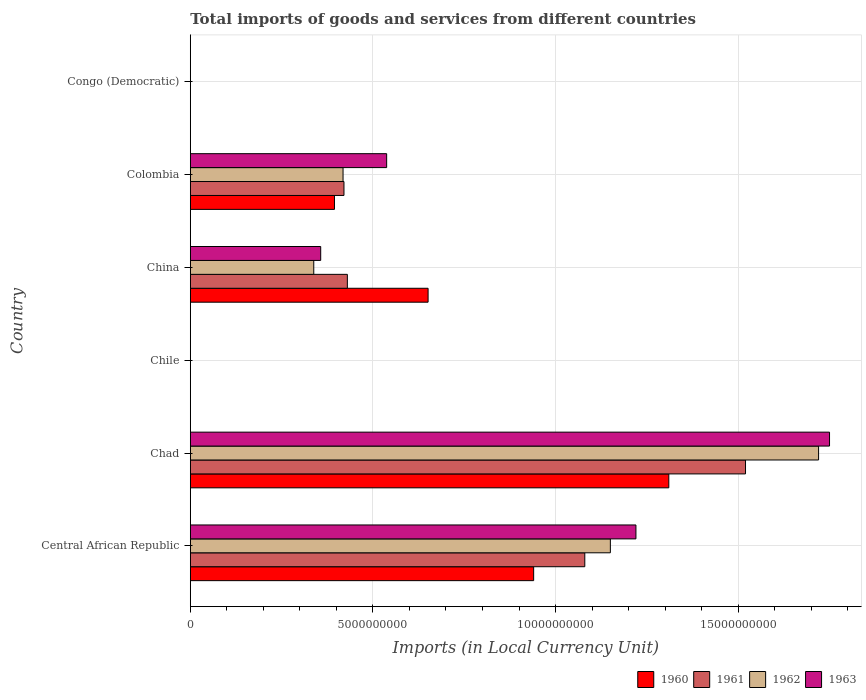Are the number of bars on each tick of the Y-axis equal?
Your answer should be very brief. Yes. How many bars are there on the 2nd tick from the top?
Provide a succinct answer. 4. How many bars are there on the 6th tick from the bottom?
Give a very brief answer. 4. What is the label of the 3rd group of bars from the top?
Give a very brief answer. China. What is the Amount of goods and services imports in 1960 in Central African Republic?
Give a very brief answer. 9.40e+09. Across all countries, what is the maximum Amount of goods and services imports in 1960?
Give a very brief answer. 1.31e+1. Across all countries, what is the minimum Amount of goods and services imports in 1960?
Your answer should be compact. 0. In which country was the Amount of goods and services imports in 1961 maximum?
Offer a very short reply. Chad. In which country was the Amount of goods and services imports in 1961 minimum?
Offer a very short reply. Congo (Democratic). What is the total Amount of goods and services imports in 1961 in the graph?
Your response must be concise. 3.45e+1. What is the difference between the Amount of goods and services imports in 1961 in Central African Republic and that in China?
Offer a terse response. 6.50e+09. What is the difference between the Amount of goods and services imports in 1962 in Chad and the Amount of goods and services imports in 1960 in Colombia?
Provide a succinct answer. 1.33e+1. What is the average Amount of goods and services imports in 1962 per country?
Your answer should be very brief. 6.04e+09. What is the difference between the Amount of goods and services imports in 1962 and Amount of goods and services imports in 1960 in Congo (Democratic)?
Make the answer very short. -5.182202221476458e-5. What is the ratio of the Amount of goods and services imports in 1962 in Chad to that in Colombia?
Ensure brevity in your answer.  4.11. Is the Amount of goods and services imports in 1963 in Central African Republic less than that in China?
Offer a terse response. No. Is the difference between the Amount of goods and services imports in 1962 in Central African Republic and Chile greater than the difference between the Amount of goods and services imports in 1960 in Central African Republic and Chile?
Provide a succinct answer. Yes. What is the difference between the highest and the second highest Amount of goods and services imports in 1960?
Offer a very short reply. 3.70e+09. What is the difference between the highest and the lowest Amount of goods and services imports in 1960?
Your response must be concise. 1.31e+1. In how many countries, is the Amount of goods and services imports in 1960 greater than the average Amount of goods and services imports in 1960 taken over all countries?
Ensure brevity in your answer.  3. Is the sum of the Amount of goods and services imports in 1960 in Central African Republic and China greater than the maximum Amount of goods and services imports in 1962 across all countries?
Keep it short and to the point. No. Is it the case that in every country, the sum of the Amount of goods and services imports in 1961 and Amount of goods and services imports in 1960 is greater than the sum of Amount of goods and services imports in 1963 and Amount of goods and services imports in 1962?
Make the answer very short. No. Is it the case that in every country, the sum of the Amount of goods and services imports in 1960 and Amount of goods and services imports in 1962 is greater than the Amount of goods and services imports in 1963?
Offer a terse response. No. How many bars are there?
Offer a terse response. 24. Are all the bars in the graph horizontal?
Keep it short and to the point. Yes. How are the legend labels stacked?
Provide a succinct answer. Horizontal. What is the title of the graph?
Offer a very short reply. Total imports of goods and services from different countries. Does "2015" appear as one of the legend labels in the graph?
Give a very brief answer. No. What is the label or title of the X-axis?
Provide a succinct answer. Imports (in Local Currency Unit). What is the Imports (in Local Currency Unit) in 1960 in Central African Republic?
Ensure brevity in your answer.  9.40e+09. What is the Imports (in Local Currency Unit) in 1961 in Central African Republic?
Your answer should be compact. 1.08e+1. What is the Imports (in Local Currency Unit) in 1962 in Central African Republic?
Keep it short and to the point. 1.15e+1. What is the Imports (in Local Currency Unit) in 1963 in Central African Republic?
Ensure brevity in your answer.  1.22e+1. What is the Imports (in Local Currency Unit) in 1960 in Chad?
Keep it short and to the point. 1.31e+1. What is the Imports (in Local Currency Unit) in 1961 in Chad?
Give a very brief answer. 1.52e+1. What is the Imports (in Local Currency Unit) of 1962 in Chad?
Give a very brief answer. 1.72e+1. What is the Imports (in Local Currency Unit) in 1963 in Chad?
Provide a short and direct response. 1.75e+1. What is the Imports (in Local Currency Unit) in 1960 in Chile?
Your answer should be compact. 7.00e+05. What is the Imports (in Local Currency Unit) in 1962 in Chile?
Ensure brevity in your answer.  8.00e+05. What is the Imports (in Local Currency Unit) of 1963 in Chile?
Make the answer very short. 1.30e+06. What is the Imports (in Local Currency Unit) of 1960 in China?
Your response must be concise. 6.51e+09. What is the Imports (in Local Currency Unit) in 1961 in China?
Make the answer very short. 4.30e+09. What is the Imports (in Local Currency Unit) in 1962 in China?
Make the answer very short. 3.38e+09. What is the Imports (in Local Currency Unit) of 1963 in China?
Keep it short and to the point. 3.57e+09. What is the Imports (in Local Currency Unit) in 1960 in Colombia?
Provide a succinct answer. 3.95e+09. What is the Imports (in Local Currency Unit) in 1961 in Colombia?
Provide a succinct answer. 4.21e+09. What is the Imports (in Local Currency Unit) of 1962 in Colombia?
Provide a succinct answer. 4.18e+09. What is the Imports (in Local Currency Unit) in 1963 in Colombia?
Provide a succinct answer. 5.38e+09. What is the Imports (in Local Currency Unit) in 1960 in Congo (Democratic)?
Make the answer very short. 0. What is the Imports (in Local Currency Unit) in 1961 in Congo (Democratic)?
Your answer should be compact. 5.07076656504069e-5. What is the Imports (in Local Currency Unit) of 1962 in Congo (Democratic)?
Your answer should be compact. 5.906629303353841e-5. What is the Imports (in Local Currency Unit) in 1963 in Congo (Democratic)?
Make the answer very short. 0. Across all countries, what is the maximum Imports (in Local Currency Unit) of 1960?
Ensure brevity in your answer.  1.31e+1. Across all countries, what is the maximum Imports (in Local Currency Unit) in 1961?
Your response must be concise. 1.52e+1. Across all countries, what is the maximum Imports (in Local Currency Unit) in 1962?
Keep it short and to the point. 1.72e+1. Across all countries, what is the maximum Imports (in Local Currency Unit) in 1963?
Keep it short and to the point. 1.75e+1. Across all countries, what is the minimum Imports (in Local Currency Unit) of 1960?
Keep it short and to the point. 0. Across all countries, what is the minimum Imports (in Local Currency Unit) of 1961?
Keep it short and to the point. 5.07076656504069e-5. Across all countries, what is the minimum Imports (in Local Currency Unit) in 1962?
Your answer should be very brief. 5.906629303353841e-5. Across all countries, what is the minimum Imports (in Local Currency Unit) in 1963?
Your answer should be very brief. 0. What is the total Imports (in Local Currency Unit) in 1960 in the graph?
Provide a succinct answer. 3.30e+1. What is the total Imports (in Local Currency Unit) in 1961 in the graph?
Offer a terse response. 3.45e+1. What is the total Imports (in Local Currency Unit) of 1962 in the graph?
Make the answer very short. 3.63e+1. What is the total Imports (in Local Currency Unit) of 1963 in the graph?
Make the answer very short. 3.86e+1. What is the difference between the Imports (in Local Currency Unit) of 1960 in Central African Republic and that in Chad?
Provide a succinct answer. -3.70e+09. What is the difference between the Imports (in Local Currency Unit) in 1961 in Central African Republic and that in Chad?
Provide a short and direct response. -4.40e+09. What is the difference between the Imports (in Local Currency Unit) of 1962 in Central African Republic and that in Chad?
Offer a terse response. -5.70e+09. What is the difference between the Imports (in Local Currency Unit) of 1963 in Central African Republic and that in Chad?
Offer a very short reply. -5.30e+09. What is the difference between the Imports (in Local Currency Unit) in 1960 in Central African Republic and that in Chile?
Provide a succinct answer. 9.40e+09. What is the difference between the Imports (in Local Currency Unit) of 1961 in Central African Republic and that in Chile?
Ensure brevity in your answer.  1.08e+1. What is the difference between the Imports (in Local Currency Unit) in 1962 in Central African Republic and that in Chile?
Provide a succinct answer. 1.15e+1. What is the difference between the Imports (in Local Currency Unit) in 1963 in Central African Republic and that in Chile?
Your answer should be compact. 1.22e+1. What is the difference between the Imports (in Local Currency Unit) of 1960 in Central African Republic and that in China?
Make the answer very short. 2.89e+09. What is the difference between the Imports (in Local Currency Unit) in 1961 in Central African Republic and that in China?
Keep it short and to the point. 6.50e+09. What is the difference between the Imports (in Local Currency Unit) in 1962 in Central African Republic and that in China?
Offer a terse response. 8.12e+09. What is the difference between the Imports (in Local Currency Unit) in 1963 in Central African Republic and that in China?
Give a very brief answer. 8.63e+09. What is the difference between the Imports (in Local Currency Unit) in 1960 in Central African Republic and that in Colombia?
Keep it short and to the point. 5.45e+09. What is the difference between the Imports (in Local Currency Unit) of 1961 in Central African Republic and that in Colombia?
Provide a short and direct response. 6.59e+09. What is the difference between the Imports (in Local Currency Unit) in 1962 in Central African Republic and that in Colombia?
Your response must be concise. 7.32e+09. What is the difference between the Imports (in Local Currency Unit) of 1963 in Central African Republic and that in Colombia?
Your answer should be very brief. 6.82e+09. What is the difference between the Imports (in Local Currency Unit) in 1960 in Central African Republic and that in Congo (Democratic)?
Offer a terse response. 9.40e+09. What is the difference between the Imports (in Local Currency Unit) of 1961 in Central African Republic and that in Congo (Democratic)?
Offer a very short reply. 1.08e+1. What is the difference between the Imports (in Local Currency Unit) of 1962 in Central African Republic and that in Congo (Democratic)?
Your answer should be very brief. 1.15e+1. What is the difference between the Imports (in Local Currency Unit) in 1963 in Central African Republic and that in Congo (Democratic)?
Provide a succinct answer. 1.22e+1. What is the difference between the Imports (in Local Currency Unit) in 1960 in Chad and that in Chile?
Your response must be concise. 1.31e+1. What is the difference between the Imports (in Local Currency Unit) in 1961 in Chad and that in Chile?
Provide a succinct answer. 1.52e+1. What is the difference between the Imports (in Local Currency Unit) of 1962 in Chad and that in Chile?
Your response must be concise. 1.72e+1. What is the difference between the Imports (in Local Currency Unit) in 1963 in Chad and that in Chile?
Provide a short and direct response. 1.75e+1. What is the difference between the Imports (in Local Currency Unit) in 1960 in Chad and that in China?
Provide a succinct answer. 6.59e+09. What is the difference between the Imports (in Local Currency Unit) of 1961 in Chad and that in China?
Make the answer very short. 1.09e+1. What is the difference between the Imports (in Local Currency Unit) in 1962 in Chad and that in China?
Give a very brief answer. 1.38e+1. What is the difference between the Imports (in Local Currency Unit) in 1963 in Chad and that in China?
Your answer should be compact. 1.39e+1. What is the difference between the Imports (in Local Currency Unit) of 1960 in Chad and that in Colombia?
Give a very brief answer. 9.15e+09. What is the difference between the Imports (in Local Currency Unit) of 1961 in Chad and that in Colombia?
Give a very brief answer. 1.10e+1. What is the difference between the Imports (in Local Currency Unit) in 1962 in Chad and that in Colombia?
Keep it short and to the point. 1.30e+1. What is the difference between the Imports (in Local Currency Unit) of 1963 in Chad and that in Colombia?
Make the answer very short. 1.21e+1. What is the difference between the Imports (in Local Currency Unit) of 1960 in Chad and that in Congo (Democratic)?
Provide a succinct answer. 1.31e+1. What is the difference between the Imports (in Local Currency Unit) of 1961 in Chad and that in Congo (Democratic)?
Your answer should be compact. 1.52e+1. What is the difference between the Imports (in Local Currency Unit) in 1962 in Chad and that in Congo (Democratic)?
Offer a very short reply. 1.72e+1. What is the difference between the Imports (in Local Currency Unit) of 1963 in Chad and that in Congo (Democratic)?
Offer a terse response. 1.75e+1. What is the difference between the Imports (in Local Currency Unit) in 1960 in Chile and that in China?
Your answer should be compact. -6.51e+09. What is the difference between the Imports (in Local Currency Unit) of 1961 in Chile and that in China?
Your answer should be very brief. -4.30e+09. What is the difference between the Imports (in Local Currency Unit) of 1962 in Chile and that in China?
Offer a terse response. -3.38e+09. What is the difference between the Imports (in Local Currency Unit) of 1963 in Chile and that in China?
Offer a very short reply. -3.57e+09. What is the difference between the Imports (in Local Currency Unit) in 1960 in Chile and that in Colombia?
Offer a very short reply. -3.95e+09. What is the difference between the Imports (in Local Currency Unit) of 1961 in Chile and that in Colombia?
Make the answer very short. -4.21e+09. What is the difference between the Imports (in Local Currency Unit) of 1962 in Chile and that in Colombia?
Give a very brief answer. -4.18e+09. What is the difference between the Imports (in Local Currency Unit) in 1963 in Chile and that in Colombia?
Your response must be concise. -5.37e+09. What is the difference between the Imports (in Local Currency Unit) of 1960 in Chile and that in Congo (Democratic)?
Provide a short and direct response. 7.00e+05. What is the difference between the Imports (in Local Currency Unit) in 1961 in Chile and that in Congo (Democratic)?
Provide a short and direct response. 8.00e+05. What is the difference between the Imports (in Local Currency Unit) of 1962 in Chile and that in Congo (Democratic)?
Your answer should be very brief. 8.00e+05. What is the difference between the Imports (in Local Currency Unit) of 1963 in Chile and that in Congo (Democratic)?
Provide a short and direct response. 1.30e+06. What is the difference between the Imports (in Local Currency Unit) in 1960 in China and that in Colombia?
Make the answer very short. 2.56e+09. What is the difference between the Imports (in Local Currency Unit) of 1961 in China and that in Colombia?
Offer a terse response. 9.28e+07. What is the difference between the Imports (in Local Currency Unit) of 1962 in China and that in Colombia?
Give a very brief answer. -8.02e+08. What is the difference between the Imports (in Local Currency Unit) in 1963 in China and that in Colombia?
Your answer should be very brief. -1.81e+09. What is the difference between the Imports (in Local Currency Unit) in 1960 in China and that in Congo (Democratic)?
Your answer should be compact. 6.51e+09. What is the difference between the Imports (in Local Currency Unit) in 1961 in China and that in Congo (Democratic)?
Keep it short and to the point. 4.30e+09. What is the difference between the Imports (in Local Currency Unit) of 1962 in China and that in Congo (Democratic)?
Give a very brief answer. 3.38e+09. What is the difference between the Imports (in Local Currency Unit) in 1963 in China and that in Congo (Democratic)?
Your answer should be compact. 3.57e+09. What is the difference between the Imports (in Local Currency Unit) of 1960 in Colombia and that in Congo (Democratic)?
Offer a very short reply. 3.95e+09. What is the difference between the Imports (in Local Currency Unit) in 1961 in Colombia and that in Congo (Democratic)?
Ensure brevity in your answer.  4.21e+09. What is the difference between the Imports (in Local Currency Unit) in 1962 in Colombia and that in Congo (Democratic)?
Give a very brief answer. 4.18e+09. What is the difference between the Imports (in Local Currency Unit) in 1963 in Colombia and that in Congo (Democratic)?
Provide a short and direct response. 5.38e+09. What is the difference between the Imports (in Local Currency Unit) of 1960 in Central African Republic and the Imports (in Local Currency Unit) of 1961 in Chad?
Your answer should be compact. -5.80e+09. What is the difference between the Imports (in Local Currency Unit) of 1960 in Central African Republic and the Imports (in Local Currency Unit) of 1962 in Chad?
Provide a succinct answer. -7.80e+09. What is the difference between the Imports (in Local Currency Unit) in 1960 in Central African Republic and the Imports (in Local Currency Unit) in 1963 in Chad?
Give a very brief answer. -8.10e+09. What is the difference between the Imports (in Local Currency Unit) in 1961 in Central African Republic and the Imports (in Local Currency Unit) in 1962 in Chad?
Provide a succinct answer. -6.40e+09. What is the difference between the Imports (in Local Currency Unit) of 1961 in Central African Republic and the Imports (in Local Currency Unit) of 1963 in Chad?
Provide a short and direct response. -6.70e+09. What is the difference between the Imports (in Local Currency Unit) of 1962 in Central African Republic and the Imports (in Local Currency Unit) of 1963 in Chad?
Your answer should be very brief. -6.00e+09. What is the difference between the Imports (in Local Currency Unit) in 1960 in Central African Republic and the Imports (in Local Currency Unit) in 1961 in Chile?
Ensure brevity in your answer.  9.40e+09. What is the difference between the Imports (in Local Currency Unit) in 1960 in Central African Republic and the Imports (in Local Currency Unit) in 1962 in Chile?
Ensure brevity in your answer.  9.40e+09. What is the difference between the Imports (in Local Currency Unit) of 1960 in Central African Republic and the Imports (in Local Currency Unit) of 1963 in Chile?
Provide a short and direct response. 9.40e+09. What is the difference between the Imports (in Local Currency Unit) of 1961 in Central African Republic and the Imports (in Local Currency Unit) of 1962 in Chile?
Make the answer very short. 1.08e+1. What is the difference between the Imports (in Local Currency Unit) of 1961 in Central African Republic and the Imports (in Local Currency Unit) of 1963 in Chile?
Ensure brevity in your answer.  1.08e+1. What is the difference between the Imports (in Local Currency Unit) of 1962 in Central African Republic and the Imports (in Local Currency Unit) of 1963 in Chile?
Keep it short and to the point. 1.15e+1. What is the difference between the Imports (in Local Currency Unit) in 1960 in Central African Republic and the Imports (in Local Currency Unit) in 1961 in China?
Offer a very short reply. 5.10e+09. What is the difference between the Imports (in Local Currency Unit) of 1960 in Central African Republic and the Imports (in Local Currency Unit) of 1962 in China?
Keep it short and to the point. 6.02e+09. What is the difference between the Imports (in Local Currency Unit) in 1960 in Central African Republic and the Imports (in Local Currency Unit) in 1963 in China?
Make the answer very short. 5.83e+09. What is the difference between the Imports (in Local Currency Unit) of 1961 in Central African Republic and the Imports (in Local Currency Unit) of 1962 in China?
Keep it short and to the point. 7.42e+09. What is the difference between the Imports (in Local Currency Unit) in 1961 in Central African Republic and the Imports (in Local Currency Unit) in 1963 in China?
Offer a very short reply. 7.23e+09. What is the difference between the Imports (in Local Currency Unit) in 1962 in Central African Republic and the Imports (in Local Currency Unit) in 1963 in China?
Provide a succinct answer. 7.93e+09. What is the difference between the Imports (in Local Currency Unit) in 1960 in Central African Republic and the Imports (in Local Currency Unit) in 1961 in Colombia?
Your response must be concise. 5.19e+09. What is the difference between the Imports (in Local Currency Unit) of 1960 in Central African Republic and the Imports (in Local Currency Unit) of 1962 in Colombia?
Make the answer very short. 5.22e+09. What is the difference between the Imports (in Local Currency Unit) of 1960 in Central African Republic and the Imports (in Local Currency Unit) of 1963 in Colombia?
Keep it short and to the point. 4.02e+09. What is the difference between the Imports (in Local Currency Unit) in 1961 in Central African Republic and the Imports (in Local Currency Unit) in 1962 in Colombia?
Offer a terse response. 6.62e+09. What is the difference between the Imports (in Local Currency Unit) in 1961 in Central African Republic and the Imports (in Local Currency Unit) in 1963 in Colombia?
Give a very brief answer. 5.42e+09. What is the difference between the Imports (in Local Currency Unit) of 1962 in Central African Republic and the Imports (in Local Currency Unit) of 1963 in Colombia?
Your response must be concise. 6.12e+09. What is the difference between the Imports (in Local Currency Unit) of 1960 in Central African Republic and the Imports (in Local Currency Unit) of 1961 in Congo (Democratic)?
Provide a succinct answer. 9.40e+09. What is the difference between the Imports (in Local Currency Unit) in 1960 in Central African Republic and the Imports (in Local Currency Unit) in 1962 in Congo (Democratic)?
Offer a very short reply. 9.40e+09. What is the difference between the Imports (in Local Currency Unit) in 1960 in Central African Republic and the Imports (in Local Currency Unit) in 1963 in Congo (Democratic)?
Offer a terse response. 9.40e+09. What is the difference between the Imports (in Local Currency Unit) in 1961 in Central African Republic and the Imports (in Local Currency Unit) in 1962 in Congo (Democratic)?
Provide a succinct answer. 1.08e+1. What is the difference between the Imports (in Local Currency Unit) in 1961 in Central African Republic and the Imports (in Local Currency Unit) in 1963 in Congo (Democratic)?
Offer a very short reply. 1.08e+1. What is the difference between the Imports (in Local Currency Unit) in 1962 in Central African Republic and the Imports (in Local Currency Unit) in 1963 in Congo (Democratic)?
Give a very brief answer. 1.15e+1. What is the difference between the Imports (in Local Currency Unit) of 1960 in Chad and the Imports (in Local Currency Unit) of 1961 in Chile?
Make the answer very short. 1.31e+1. What is the difference between the Imports (in Local Currency Unit) of 1960 in Chad and the Imports (in Local Currency Unit) of 1962 in Chile?
Give a very brief answer. 1.31e+1. What is the difference between the Imports (in Local Currency Unit) of 1960 in Chad and the Imports (in Local Currency Unit) of 1963 in Chile?
Your answer should be very brief. 1.31e+1. What is the difference between the Imports (in Local Currency Unit) of 1961 in Chad and the Imports (in Local Currency Unit) of 1962 in Chile?
Offer a terse response. 1.52e+1. What is the difference between the Imports (in Local Currency Unit) in 1961 in Chad and the Imports (in Local Currency Unit) in 1963 in Chile?
Provide a short and direct response. 1.52e+1. What is the difference between the Imports (in Local Currency Unit) in 1962 in Chad and the Imports (in Local Currency Unit) in 1963 in Chile?
Provide a succinct answer. 1.72e+1. What is the difference between the Imports (in Local Currency Unit) of 1960 in Chad and the Imports (in Local Currency Unit) of 1961 in China?
Ensure brevity in your answer.  8.80e+09. What is the difference between the Imports (in Local Currency Unit) in 1960 in Chad and the Imports (in Local Currency Unit) in 1962 in China?
Provide a succinct answer. 9.72e+09. What is the difference between the Imports (in Local Currency Unit) in 1960 in Chad and the Imports (in Local Currency Unit) in 1963 in China?
Provide a short and direct response. 9.53e+09. What is the difference between the Imports (in Local Currency Unit) of 1961 in Chad and the Imports (in Local Currency Unit) of 1962 in China?
Offer a terse response. 1.18e+1. What is the difference between the Imports (in Local Currency Unit) in 1961 in Chad and the Imports (in Local Currency Unit) in 1963 in China?
Provide a succinct answer. 1.16e+1. What is the difference between the Imports (in Local Currency Unit) in 1962 in Chad and the Imports (in Local Currency Unit) in 1963 in China?
Provide a succinct answer. 1.36e+1. What is the difference between the Imports (in Local Currency Unit) in 1960 in Chad and the Imports (in Local Currency Unit) in 1961 in Colombia?
Your response must be concise. 8.89e+09. What is the difference between the Imports (in Local Currency Unit) of 1960 in Chad and the Imports (in Local Currency Unit) of 1962 in Colombia?
Give a very brief answer. 8.92e+09. What is the difference between the Imports (in Local Currency Unit) of 1960 in Chad and the Imports (in Local Currency Unit) of 1963 in Colombia?
Provide a short and direct response. 7.72e+09. What is the difference between the Imports (in Local Currency Unit) of 1961 in Chad and the Imports (in Local Currency Unit) of 1962 in Colombia?
Your answer should be compact. 1.10e+1. What is the difference between the Imports (in Local Currency Unit) of 1961 in Chad and the Imports (in Local Currency Unit) of 1963 in Colombia?
Your response must be concise. 9.82e+09. What is the difference between the Imports (in Local Currency Unit) in 1962 in Chad and the Imports (in Local Currency Unit) in 1963 in Colombia?
Offer a very short reply. 1.18e+1. What is the difference between the Imports (in Local Currency Unit) in 1960 in Chad and the Imports (in Local Currency Unit) in 1961 in Congo (Democratic)?
Give a very brief answer. 1.31e+1. What is the difference between the Imports (in Local Currency Unit) of 1960 in Chad and the Imports (in Local Currency Unit) of 1962 in Congo (Democratic)?
Ensure brevity in your answer.  1.31e+1. What is the difference between the Imports (in Local Currency Unit) in 1960 in Chad and the Imports (in Local Currency Unit) in 1963 in Congo (Democratic)?
Offer a very short reply. 1.31e+1. What is the difference between the Imports (in Local Currency Unit) in 1961 in Chad and the Imports (in Local Currency Unit) in 1962 in Congo (Democratic)?
Make the answer very short. 1.52e+1. What is the difference between the Imports (in Local Currency Unit) in 1961 in Chad and the Imports (in Local Currency Unit) in 1963 in Congo (Democratic)?
Your response must be concise. 1.52e+1. What is the difference between the Imports (in Local Currency Unit) in 1962 in Chad and the Imports (in Local Currency Unit) in 1963 in Congo (Democratic)?
Provide a succinct answer. 1.72e+1. What is the difference between the Imports (in Local Currency Unit) in 1960 in Chile and the Imports (in Local Currency Unit) in 1961 in China?
Your response must be concise. -4.30e+09. What is the difference between the Imports (in Local Currency Unit) of 1960 in Chile and the Imports (in Local Currency Unit) of 1962 in China?
Ensure brevity in your answer.  -3.38e+09. What is the difference between the Imports (in Local Currency Unit) in 1960 in Chile and the Imports (in Local Currency Unit) in 1963 in China?
Offer a terse response. -3.57e+09. What is the difference between the Imports (in Local Currency Unit) in 1961 in Chile and the Imports (in Local Currency Unit) in 1962 in China?
Provide a succinct answer. -3.38e+09. What is the difference between the Imports (in Local Currency Unit) in 1961 in Chile and the Imports (in Local Currency Unit) in 1963 in China?
Your response must be concise. -3.57e+09. What is the difference between the Imports (in Local Currency Unit) of 1962 in Chile and the Imports (in Local Currency Unit) of 1963 in China?
Your answer should be compact. -3.57e+09. What is the difference between the Imports (in Local Currency Unit) in 1960 in Chile and the Imports (in Local Currency Unit) in 1961 in Colombia?
Provide a succinct answer. -4.21e+09. What is the difference between the Imports (in Local Currency Unit) in 1960 in Chile and the Imports (in Local Currency Unit) in 1962 in Colombia?
Your answer should be very brief. -4.18e+09. What is the difference between the Imports (in Local Currency Unit) in 1960 in Chile and the Imports (in Local Currency Unit) in 1963 in Colombia?
Your answer should be very brief. -5.37e+09. What is the difference between the Imports (in Local Currency Unit) in 1961 in Chile and the Imports (in Local Currency Unit) in 1962 in Colombia?
Provide a succinct answer. -4.18e+09. What is the difference between the Imports (in Local Currency Unit) of 1961 in Chile and the Imports (in Local Currency Unit) of 1963 in Colombia?
Keep it short and to the point. -5.37e+09. What is the difference between the Imports (in Local Currency Unit) in 1962 in Chile and the Imports (in Local Currency Unit) in 1963 in Colombia?
Provide a short and direct response. -5.37e+09. What is the difference between the Imports (in Local Currency Unit) in 1960 in Chile and the Imports (in Local Currency Unit) in 1961 in Congo (Democratic)?
Provide a short and direct response. 7.00e+05. What is the difference between the Imports (in Local Currency Unit) in 1960 in Chile and the Imports (in Local Currency Unit) in 1962 in Congo (Democratic)?
Offer a terse response. 7.00e+05. What is the difference between the Imports (in Local Currency Unit) in 1960 in Chile and the Imports (in Local Currency Unit) in 1963 in Congo (Democratic)?
Offer a very short reply. 7.00e+05. What is the difference between the Imports (in Local Currency Unit) of 1961 in Chile and the Imports (in Local Currency Unit) of 1962 in Congo (Democratic)?
Your answer should be very brief. 8.00e+05. What is the difference between the Imports (in Local Currency Unit) of 1961 in Chile and the Imports (in Local Currency Unit) of 1963 in Congo (Democratic)?
Provide a short and direct response. 8.00e+05. What is the difference between the Imports (in Local Currency Unit) of 1962 in Chile and the Imports (in Local Currency Unit) of 1963 in Congo (Democratic)?
Your answer should be very brief. 8.00e+05. What is the difference between the Imports (in Local Currency Unit) in 1960 in China and the Imports (in Local Currency Unit) in 1961 in Colombia?
Your response must be concise. 2.30e+09. What is the difference between the Imports (in Local Currency Unit) in 1960 in China and the Imports (in Local Currency Unit) in 1962 in Colombia?
Your answer should be compact. 2.33e+09. What is the difference between the Imports (in Local Currency Unit) of 1960 in China and the Imports (in Local Currency Unit) of 1963 in Colombia?
Provide a short and direct response. 1.13e+09. What is the difference between the Imports (in Local Currency Unit) in 1961 in China and the Imports (in Local Currency Unit) in 1962 in Colombia?
Your response must be concise. 1.18e+08. What is the difference between the Imports (in Local Currency Unit) of 1961 in China and the Imports (in Local Currency Unit) of 1963 in Colombia?
Provide a succinct answer. -1.08e+09. What is the difference between the Imports (in Local Currency Unit) of 1962 in China and the Imports (in Local Currency Unit) of 1963 in Colombia?
Ensure brevity in your answer.  -2.00e+09. What is the difference between the Imports (in Local Currency Unit) in 1960 in China and the Imports (in Local Currency Unit) in 1961 in Congo (Democratic)?
Offer a very short reply. 6.51e+09. What is the difference between the Imports (in Local Currency Unit) of 1960 in China and the Imports (in Local Currency Unit) of 1962 in Congo (Democratic)?
Offer a very short reply. 6.51e+09. What is the difference between the Imports (in Local Currency Unit) in 1960 in China and the Imports (in Local Currency Unit) in 1963 in Congo (Democratic)?
Keep it short and to the point. 6.51e+09. What is the difference between the Imports (in Local Currency Unit) of 1961 in China and the Imports (in Local Currency Unit) of 1962 in Congo (Democratic)?
Offer a very short reply. 4.30e+09. What is the difference between the Imports (in Local Currency Unit) of 1961 in China and the Imports (in Local Currency Unit) of 1963 in Congo (Democratic)?
Your answer should be compact. 4.30e+09. What is the difference between the Imports (in Local Currency Unit) of 1962 in China and the Imports (in Local Currency Unit) of 1963 in Congo (Democratic)?
Offer a very short reply. 3.38e+09. What is the difference between the Imports (in Local Currency Unit) in 1960 in Colombia and the Imports (in Local Currency Unit) in 1961 in Congo (Democratic)?
Your answer should be very brief. 3.95e+09. What is the difference between the Imports (in Local Currency Unit) of 1960 in Colombia and the Imports (in Local Currency Unit) of 1962 in Congo (Democratic)?
Keep it short and to the point. 3.95e+09. What is the difference between the Imports (in Local Currency Unit) of 1960 in Colombia and the Imports (in Local Currency Unit) of 1963 in Congo (Democratic)?
Your answer should be compact. 3.95e+09. What is the difference between the Imports (in Local Currency Unit) in 1961 in Colombia and the Imports (in Local Currency Unit) in 1962 in Congo (Democratic)?
Your answer should be very brief. 4.21e+09. What is the difference between the Imports (in Local Currency Unit) of 1961 in Colombia and the Imports (in Local Currency Unit) of 1963 in Congo (Democratic)?
Provide a short and direct response. 4.21e+09. What is the difference between the Imports (in Local Currency Unit) in 1962 in Colombia and the Imports (in Local Currency Unit) in 1963 in Congo (Democratic)?
Your answer should be very brief. 4.18e+09. What is the average Imports (in Local Currency Unit) in 1960 per country?
Provide a short and direct response. 5.49e+09. What is the average Imports (in Local Currency Unit) of 1961 per country?
Ensure brevity in your answer.  5.75e+09. What is the average Imports (in Local Currency Unit) in 1962 per country?
Give a very brief answer. 6.04e+09. What is the average Imports (in Local Currency Unit) of 1963 per country?
Your answer should be compact. 6.44e+09. What is the difference between the Imports (in Local Currency Unit) in 1960 and Imports (in Local Currency Unit) in 1961 in Central African Republic?
Your answer should be very brief. -1.40e+09. What is the difference between the Imports (in Local Currency Unit) in 1960 and Imports (in Local Currency Unit) in 1962 in Central African Republic?
Make the answer very short. -2.10e+09. What is the difference between the Imports (in Local Currency Unit) in 1960 and Imports (in Local Currency Unit) in 1963 in Central African Republic?
Provide a succinct answer. -2.80e+09. What is the difference between the Imports (in Local Currency Unit) of 1961 and Imports (in Local Currency Unit) of 1962 in Central African Republic?
Your response must be concise. -7.00e+08. What is the difference between the Imports (in Local Currency Unit) of 1961 and Imports (in Local Currency Unit) of 1963 in Central African Republic?
Your answer should be very brief. -1.40e+09. What is the difference between the Imports (in Local Currency Unit) in 1962 and Imports (in Local Currency Unit) in 1963 in Central African Republic?
Make the answer very short. -7.00e+08. What is the difference between the Imports (in Local Currency Unit) in 1960 and Imports (in Local Currency Unit) in 1961 in Chad?
Give a very brief answer. -2.10e+09. What is the difference between the Imports (in Local Currency Unit) of 1960 and Imports (in Local Currency Unit) of 1962 in Chad?
Offer a terse response. -4.10e+09. What is the difference between the Imports (in Local Currency Unit) in 1960 and Imports (in Local Currency Unit) in 1963 in Chad?
Provide a short and direct response. -4.40e+09. What is the difference between the Imports (in Local Currency Unit) in 1961 and Imports (in Local Currency Unit) in 1962 in Chad?
Ensure brevity in your answer.  -2.00e+09. What is the difference between the Imports (in Local Currency Unit) of 1961 and Imports (in Local Currency Unit) of 1963 in Chad?
Make the answer very short. -2.30e+09. What is the difference between the Imports (in Local Currency Unit) of 1962 and Imports (in Local Currency Unit) of 1963 in Chad?
Ensure brevity in your answer.  -3.00e+08. What is the difference between the Imports (in Local Currency Unit) of 1960 and Imports (in Local Currency Unit) of 1961 in Chile?
Provide a short and direct response. -1.00e+05. What is the difference between the Imports (in Local Currency Unit) in 1960 and Imports (in Local Currency Unit) in 1963 in Chile?
Provide a succinct answer. -6.00e+05. What is the difference between the Imports (in Local Currency Unit) of 1961 and Imports (in Local Currency Unit) of 1963 in Chile?
Provide a succinct answer. -5.00e+05. What is the difference between the Imports (in Local Currency Unit) in 1962 and Imports (in Local Currency Unit) in 1963 in Chile?
Make the answer very short. -5.00e+05. What is the difference between the Imports (in Local Currency Unit) of 1960 and Imports (in Local Currency Unit) of 1961 in China?
Your answer should be very brief. 2.21e+09. What is the difference between the Imports (in Local Currency Unit) of 1960 and Imports (in Local Currency Unit) of 1962 in China?
Provide a succinct answer. 3.13e+09. What is the difference between the Imports (in Local Currency Unit) in 1960 and Imports (in Local Currency Unit) in 1963 in China?
Offer a very short reply. 2.94e+09. What is the difference between the Imports (in Local Currency Unit) of 1961 and Imports (in Local Currency Unit) of 1962 in China?
Offer a very short reply. 9.20e+08. What is the difference between the Imports (in Local Currency Unit) of 1961 and Imports (in Local Currency Unit) of 1963 in China?
Ensure brevity in your answer.  7.30e+08. What is the difference between the Imports (in Local Currency Unit) in 1962 and Imports (in Local Currency Unit) in 1963 in China?
Offer a terse response. -1.90e+08. What is the difference between the Imports (in Local Currency Unit) in 1960 and Imports (in Local Currency Unit) in 1961 in Colombia?
Provide a short and direct response. -2.60e+08. What is the difference between the Imports (in Local Currency Unit) of 1960 and Imports (in Local Currency Unit) of 1962 in Colombia?
Offer a terse response. -2.35e+08. What is the difference between the Imports (in Local Currency Unit) in 1960 and Imports (in Local Currency Unit) in 1963 in Colombia?
Offer a terse response. -1.43e+09. What is the difference between the Imports (in Local Currency Unit) in 1961 and Imports (in Local Currency Unit) in 1962 in Colombia?
Offer a very short reply. 2.55e+07. What is the difference between the Imports (in Local Currency Unit) in 1961 and Imports (in Local Currency Unit) in 1963 in Colombia?
Offer a very short reply. -1.17e+09. What is the difference between the Imports (in Local Currency Unit) of 1962 and Imports (in Local Currency Unit) of 1963 in Colombia?
Make the answer very short. -1.19e+09. What is the difference between the Imports (in Local Currency Unit) in 1960 and Imports (in Local Currency Unit) in 1961 in Congo (Democratic)?
Offer a very short reply. 0. What is the difference between the Imports (in Local Currency Unit) of 1960 and Imports (in Local Currency Unit) of 1963 in Congo (Democratic)?
Make the answer very short. -0. What is the difference between the Imports (in Local Currency Unit) in 1961 and Imports (in Local Currency Unit) in 1963 in Congo (Democratic)?
Provide a succinct answer. -0. What is the difference between the Imports (in Local Currency Unit) in 1962 and Imports (in Local Currency Unit) in 1963 in Congo (Democratic)?
Make the answer very short. -0. What is the ratio of the Imports (in Local Currency Unit) of 1960 in Central African Republic to that in Chad?
Ensure brevity in your answer.  0.72. What is the ratio of the Imports (in Local Currency Unit) of 1961 in Central African Republic to that in Chad?
Offer a terse response. 0.71. What is the ratio of the Imports (in Local Currency Unit) in 1962 in Central African Republic to that in Chad?
Your answer should be very brief. 0.67. What is the ratio of the Imports (in Local Currency Unit) of 1963 in Central African Republic to that in Chad?
Offer a very short reply. 0.7. What is the ratio of the Imports (in Local Currency Unit) of 1960 in Central African Republic to that in Chile?
Your answer should be very brief. 1.34e+04. What is the ratio of the Imports (in Local Currency Unit) of 1961 in Central African Republic to that in Chile?
Your answer should be compact. 1.35e+04. What is the ratio of the Imports (in Local Currency Unit) in 1962 in Central African Republic to that in Chile?
Your answer should be very brief. 1.44e+04. What is the ratio of the Imports (in Local Currency Unit) of 1963 in Central African Republic to that in Chile?
Ensure brevity in your answer.  9384.62. What is the ratio of the Imports (in Local Currency Unit) of 1960 in Central African Republic to that in China?
Make the answer very short. 1.44. What is the ratio of the Imports (in Local Currency Unit) in 1961 in Central African Republic to that in China?
Ensure brevity in your answer.  2.51. What is the ratio of the Imports (in Local Currency Unit) in 1962 in Central African Republic to that in China?
Provide a short and direct response. 3.4. What is the ratio of the Imports (in Local Currency Unit) in 1963 in Central African Republic to that in China?
Ensure brevity in your answer.  3.42. What is the ratio of the Imports (in Local Currency Unit) of 1960 in Central African Republic to that in Colombia?
Keep it short and to the point. 2.38. What is the ratio of the Imports (in Local Currency Unit) of 1961 in Central African Republic to that in Colombia?
Your answer should be compact. 2.57. What is the ratio of the Imports (in Local Currency Unit) of 1962 in Central African Republic to that in Colombia?
Keep it short and to the point. 2.75. What is the ratio of the Imports (in Local Currency Unit) of 1963 in Central African Republic to that in Colombia?
Ensure brevity in your answer.  2.27. What is the ratio of the Imports (in Local Currency Unit) of 1960 in Central African Republic to that in Congo (Democratic)?
Give a very brief answer. 8.48e+13. What is the ratio of the Imports (in Local Currency Unit) of 1961 in Central African Republic to that in Congo (Democratic)?
Your response must be concise. 2.13e+14. What is the ratio of the Imports (in Local Currency Unit) in 1962 in Central African Republic to that in Congo (Democratic)?
Offer a very short reply. 1.95e+14. What is the ratio of the Imports (in Local Currency Unit) in 1963 in Central African Republic to that in Congo (Democratic)?
Provide a short and direct response. 2.45e+13. What is the ratio of the Imports (in Local Currency Unit) of 1960 in Chad to that in Chile?
Make the answer very short. 1.87e+04. What is the ratio of the Imports (in Local Currency Unit) in 1961 in Chad to that in Chile?
Make the answer very short. 1.90e+04. What is the ratio of the Imports (in Local Currency Unit) in 1962 in Chad to that in Chile?
Make the answer very short. 2.15e+04. What is the ratio of the Imports (in Local Currency Unit) of 1963 in Chad to that in Chile?
Offer a very short reply. 1.35e+04. What is the ratio of the Imports (in Local Currency Unit) of 1960 in Chad to that in China?
Make the answer very short. 2.01. What is the ratio of the Imports (in Local Currency Unit) of 1961 in Chad to that in China?
Give a very brief answer. 3.53. What is the ratio of the Imports (in Local Currency Unit) of 1962 in Chad to that in China?
Offer a very short reply. 5.09. What is the ratio of the Imports (in Local Currency Unit) in 1963 in Chad to that in China?
Give a very brief answer. 4.9. What is the ratio of the Imports (in Local Currency Unit) of 1960 in Chad to that in Colombia?
Give a very brief answer. 3.32. What is the ratio of the Imports (in Local Currency Unit) in 1961 in Chad to that in Colombia?
Give a very brief answer. 3.61. What is the ratio of the Imports (in Local Currency Unit) of 1962 in Chad to that in Colombia?
Ensure brevity in your answer.  4.11. What is the ratio of the Imports (in Local Currency Unit) of 1963 in Chad to that in Colombia?
Offer a terse response. 3.26. What is the ratio of the Imports (in Local Currency Unit) of 1960 in Chad to that in Congo (Democratic)?
Your response must be concise. 1.18e+14. What is the ratio of the Imports (in Local Currency Unit) in 1961 in Chad to that in Congo (Democratic)?
Offer a terse response. 3.00e+14. What is the ratio of the Imports (in Local Currency Unit) in 1962 in Chad to that in Congo (Democratic)?
Offer a terse response. 2.91e+14. What is the ratio of the Imports (in Local Currency Unit) in 1963 in Chad to that in Congo (Democratic)?
Provide a short and direct response. 3.52e+13. What is the ratio of the Imports (in Local Currency Unit) of 1961 in Chile to that in China?
Your answer should be very brief. 0. What is the ratio of the Imports (in Local Currency Unit) of 1960 in Chile to that in Colombia?
Provide a succinct answer. 0. What is the ratio of the Imports (in Local Currency Unit) in 1962 in Chile to that in Colombia?
Your answer should be very brief. 0. What is the ratio of the Imports (in Local Currency Unit) of 1960 in Chile to that in Congo (Democratic)?
Give a very brief answer. 6.31e+09. What is the ratio of the Imports (in Local Currency Unit) in 1961 in Chile to that in Congo (Democratic)?
Ensure brevity in your answer.  1.58e+1. What is the ratio of the Imports (in Local Currency Unit) of 1962 in Chile to that in Congo (Democratic)?
Your answer should be compact. 1.35e+1. What is the ratio of the Imports (in Local Currency Unit) in 1963 in Chile to that in Congo (Democratic)?
Your answer should be very brief. 2.62e+09. What is the ratio of the Imports (in Local Currency Unit) of 1960 in China to that in Colombia?
Make the answer very short. 1.65. What is the ratio of the Imports (in Local Currency Unit) in 1961 in China to that in Colombia?
Offer a terse response. 1.02. What is the ratio of the Imports (in Local Currency Unit) of 1962 in China to that in Colombia?
Offer a terse response. 0.81. What is the ratio of the Imports (in Local Currency Unit) of 1963 in China to that in Colombia?
Keep it short and to the point. 0.66. What is the ratio of the Imports (in Local Currency Unit) in 1960 in China to that in Congo (Democratic)?
Provide a short and direct response. 5.87e+13. What is the ratio of the Imports (in Local Currency Unit) in 1961 in China to that in Congo (Democratic)?
Give a very brief answer. 8.48e+13. What is the ratio of the Imports (in Local Currency Unit) in 1962 in China to that in Congo (Democratic)?
Your response must be concise. 5.72e+13. What is the ratio of the Imports (in Local Currency Unit) of 1963 in China to that in Congo (Democratic)?
Ensure brevity in your answer.  7.18e+12. What is the ratio of the Imports (in Local Currency Unit) in 1960 in Colombia to that in Congo (Democratic)?
Make the answer very short. 3.56e+13. What is the ratio of the Imports (in Local Currency Unit) of 1961 in Colombia to that in Congo (Democratic)?
Make the answer very short. 8.30e+13. What is the ratio of the Imports (in Local Currency Unit) in 1962 in Colombia to that in Congo (Democratic)?
Ensure brevity in your answer.  7.08e+13. What is the ratio of the Imports (in Local Currency Unit) in 1963 in Colombia to that in Congo (Democratic)?
Offer a very short reply. 1.08e+13. What is the difference between the highest and the second highest Imports (in Local Currency Unit) of 1960?
Ensure brevity in your answer.  3.70e+09. What is the difference between the highest and the second highest Imports (in Local Currency Unit) of 1961?
Make the answer very short. 4.40e+09. What is the difference between the highest and the second highest Imports (in Local Currency Unit) in 1962?
Offer a very short reply. 5.70e+09. What is the difference between the highest and the second highest Imports (in Local Currency Unit) of 1963?
Make the answer very short. 5.30e+09. What is the difference between the highest and the lowest Imports (in Local Currency Unit) in 1960?
Provide a succinct answer. 1.31e+1. What is the difference between the highest and the lowest Imports (in Local Currency Unit) of 1961?
Your answer should be compact. 1.52e+1. What is the difference between the highest and the lowest Imports (in Local Currency Unit) in 1962?
Provide a succinct answer. 1.72e+1. What is the difference between the highest and the lowest Imports (in Local Currency Unit) in 1963?
Ensure brevity in your answer.  1.75e+1. 